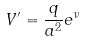Convert formula to latex. <formula><loc_0><loc_0><loc_500><loc_500>V ^ { \prime } = \frac { q } { a ^ { 2 } } e ^ { \nu }</formula> 